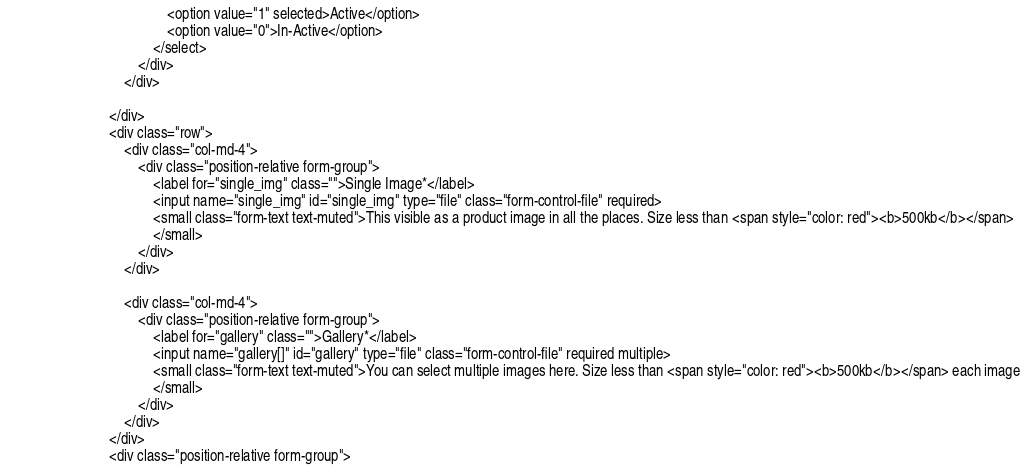Convert code to text. <code><loc_0><loc_0><loc_500><loc_500><_PHP_>                                            <option value="1" selected>Active</option>
                                            <option value="0">In-Active</option>
                                        </select>
                                    </div>
                                </div>

                            </div>
                            <div class="row">
                                <div class="col-md-4">
                                    <div class="position-relative form-group">
                                        <label for="single_img" class="">Single Image*</label>
                                        <input name="single_img" id="single_img" type="file" class="form-control-file" required>
                                        <small class="form-text text-muted">This visible as a product image in all the places. Size less than <span style="color: red"><b>500kb</b></span>
                                        </small>
                                    </div>
                                </div>

                                <div class="col-md-4">
                                    <div class="position-relative form-group">
                                        <label for="gallery" class="">Gallery*</label>
                                        <input name="gallery[]" id="gallery" type="file" class="form-control-file" required multiple>
                                        <small class="form-text text-muted">You can select multiple images here. Size less than <span style="color: red"><b>500kb</b></span> each image
                                        </small>
                                    </div>
                                </div>
                            </div>
                            <div class="position-relative form-group"></code> 